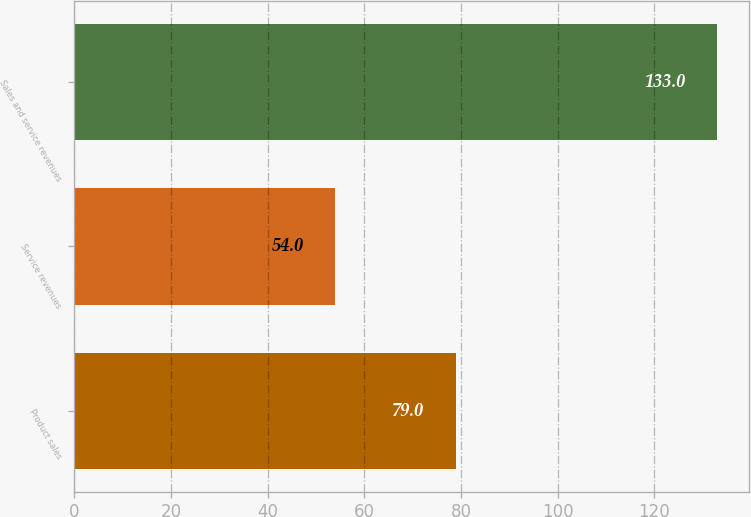Convert chart. <chart><loc_0><loc_0><loc_500><loc_500><bar_chart><fcel>Product sales<fcel>Service revenues<fcel>Sales and service revenues<nl><fcel>79<fcel>54<fcel>133<nl></chart> 